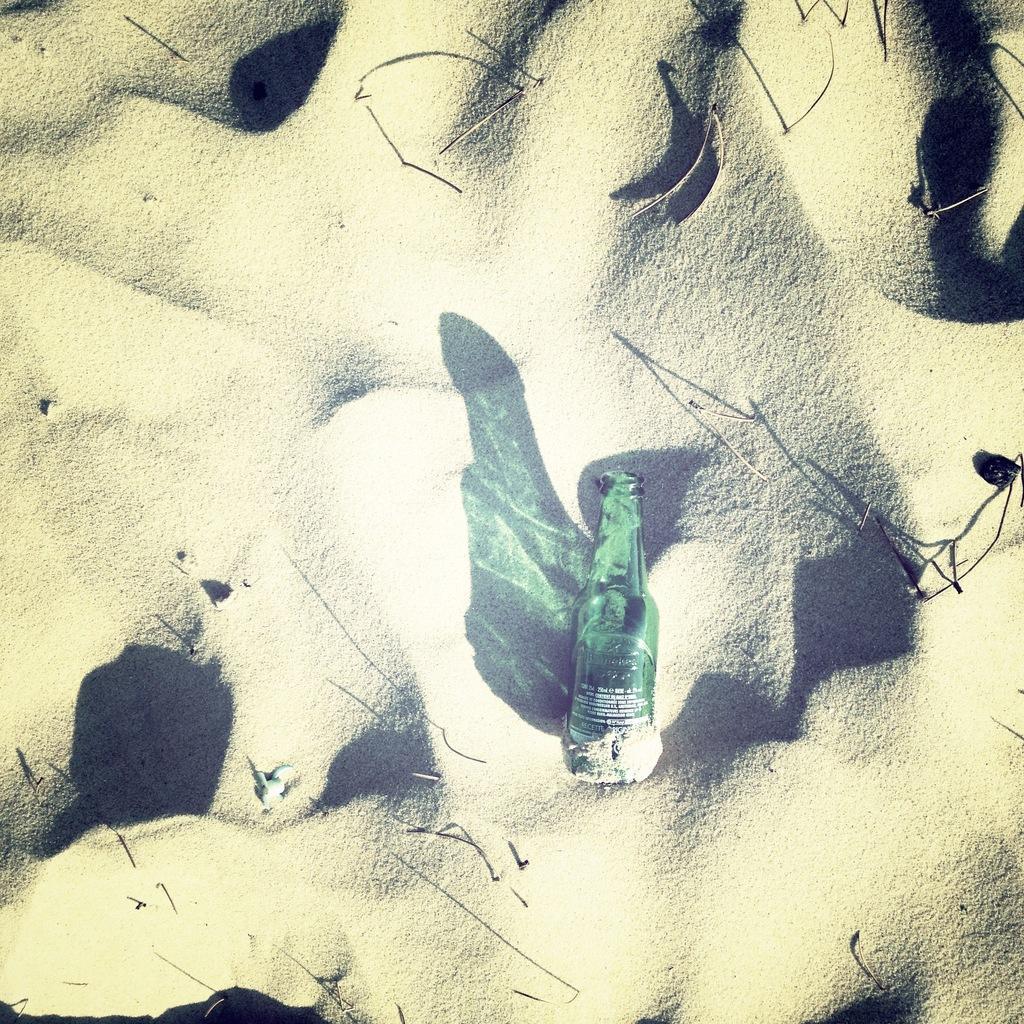Could you give a brief overview of what you see in this image? In this image In the middle there is a bottle and shadow and bottle is on sand. 